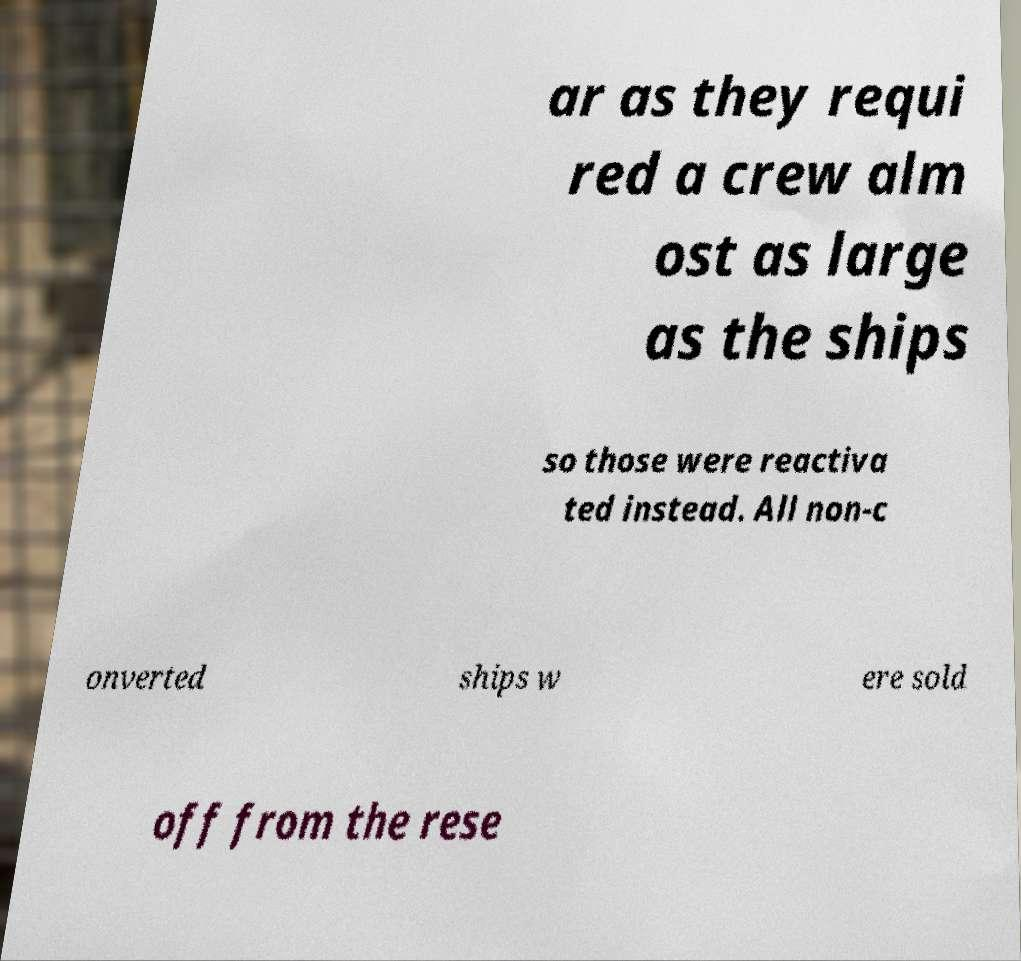Could you extract and type out the text from this image? ar as they requi red a crew alm ost as large as the ships so those were reactiva ted instead. All non-c onverted ships w ere sold off from the rese 